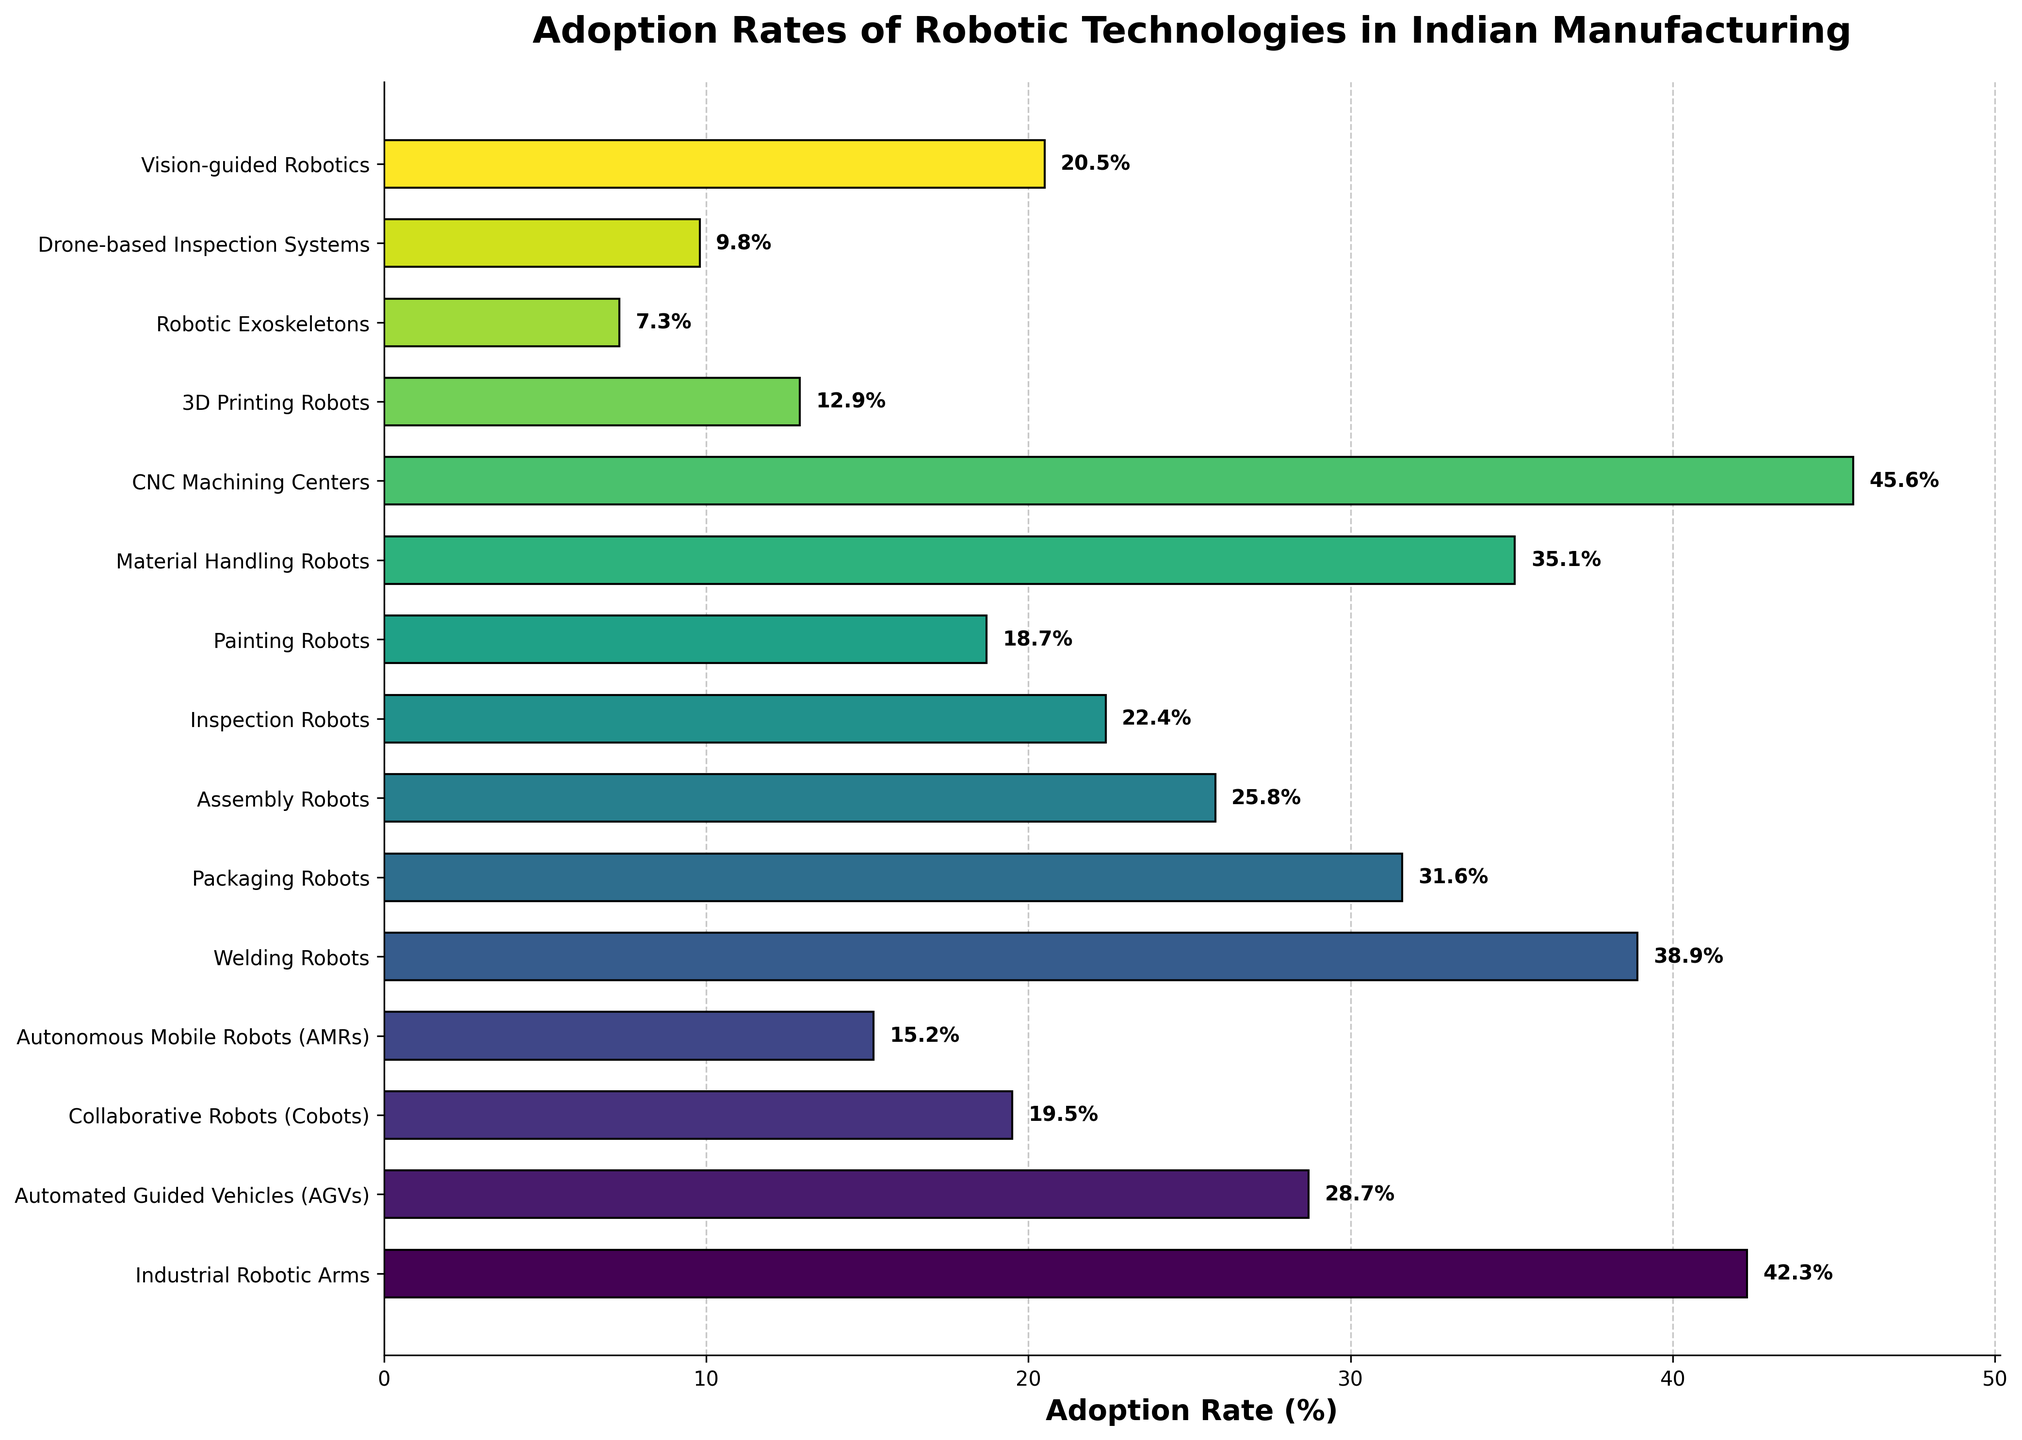What's the adoption rate of Industrial Robotic Arms? The bar corresponding to Industrial Robotic Arms reaches the 42.3% mark on the x-axis.
Answer: 42.3% Which robotic technology has the highest adoption rate? The longest bar in the plot corresponds to CNC Machining Centers, indicating the highest adoption rate.
Answer: CNC Machining Centers Which two robotic technologies have adoption rates above 40%? The bars for CNC Machining Centers and Industrial Robotic Arms both surpass the 40% mark on the x-axis.
Answer: CNC Machining Centers, Industrial Robotic Arms What is the difference in adoption rates between Welding Robots and Packaging Robots? The bar for Welding Robots reaches 38.9%, and the bar for Packaging Robots reaches 31.6%. Subtract 31.6 from 38.9 to find the difference.
Answer: 7.3% How many robotic technologies have adoption rates below 20%? The bars for Collaborative Robots (19.5%), Autonomous Mobile Robots (15.2%), 3D Printing Robots (12.9%), Robotic Exoskeletons (7.3%), Drone-based Inspection Systems (9.8%), and Painting Robots (18.7%) are below the 20% mark. Count these technologies.
Answer: 6 Which robotic technology has the closest adoption rate to 20%? Looking at the x-axis positions, Vision-guided Robotics has an adoption rate of 20.5%, which is closest to 20%.
Answer: Vision-guided Robotics Is the adoption rate of Inspection Robots higher or lower than that of Assembly Robots? The bar for Inspection Robots reaches 22.4%, while the bar for Assembly Robots reaches 25.8%. Compare these values.
Answer: Lower What is the combined adoption rate of Automated Guided Vehicles and Material Handling Robots? Add the adoption rates of Automated Guided Vehicles (28.7%) and Material Handling Robots (35.1%). 28.7 + 35.1 = 63.8
Answer: 63.8% By how much does the adoption rate of the highest technology exceed that of the lowest? The highest adoption rate is for CNC Machining Centers at 45.6% and the lowest is for Robotic Exoskeletons at 7.3%. Subtract 7.3 from 45.6 to find the difference.
Answer: 38.3% How do the adoption rates of Automated Guided Vehicles and Autonomous Mobile Robots compare visually? The bar for Automated Guided Vehicles is nearly twice as long as the bar for Autonomous Mobile Robots, showing a clear visual difference in adoption rates.
Answer: Automated Guided Vehicles have a higher adoption rate 